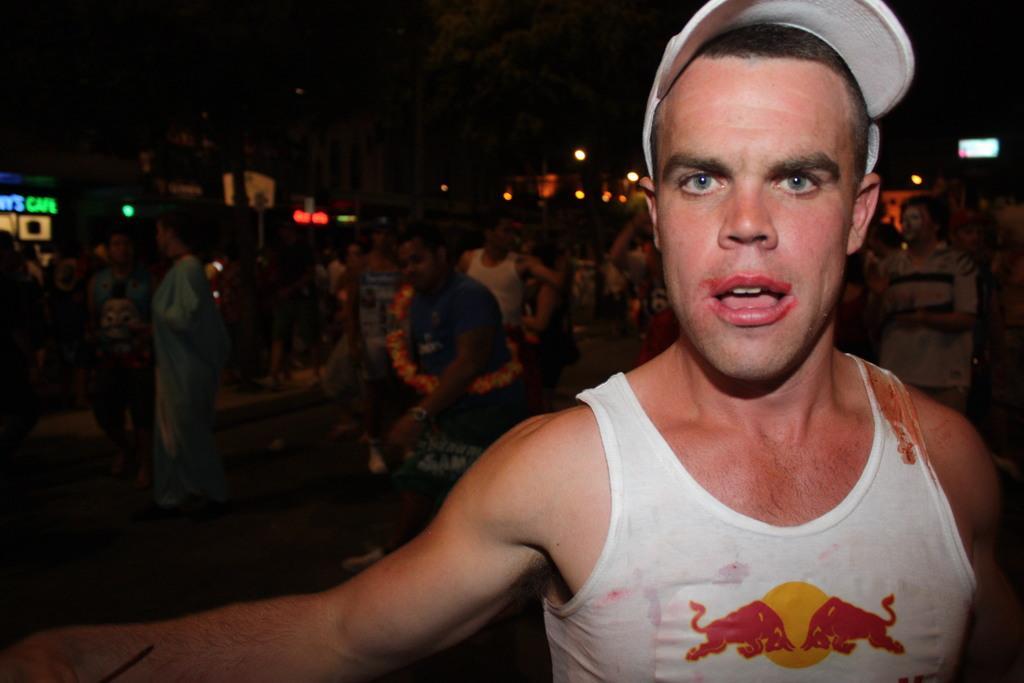How would you summarize this image in a sentence or two? In this picture we can see a man with a cap is standing on the path. Behind the women there are groups of people standing, lights and other thing and behind the people there is a dark background. 